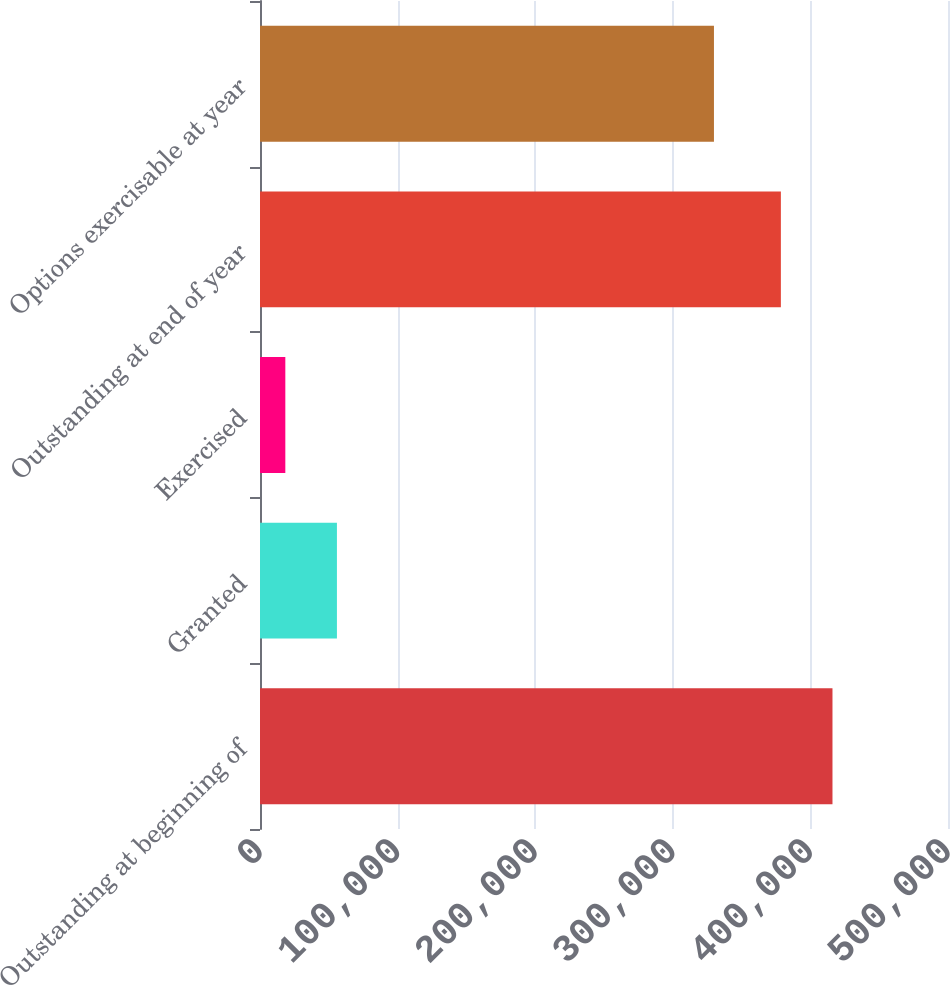<chart> <loc_0><loc_0><loc_500><loc_500><bar_chart><fcel>Outstanding at beginning of<fcel>Granted<fcel>Exercised<fcel>Outstanding at end of year<fcel>Options exercisable at year<nl><fcel>416046<fcel>55910.6<fcel>18407<fcel>378542<fcel>329909<nl></chart> 